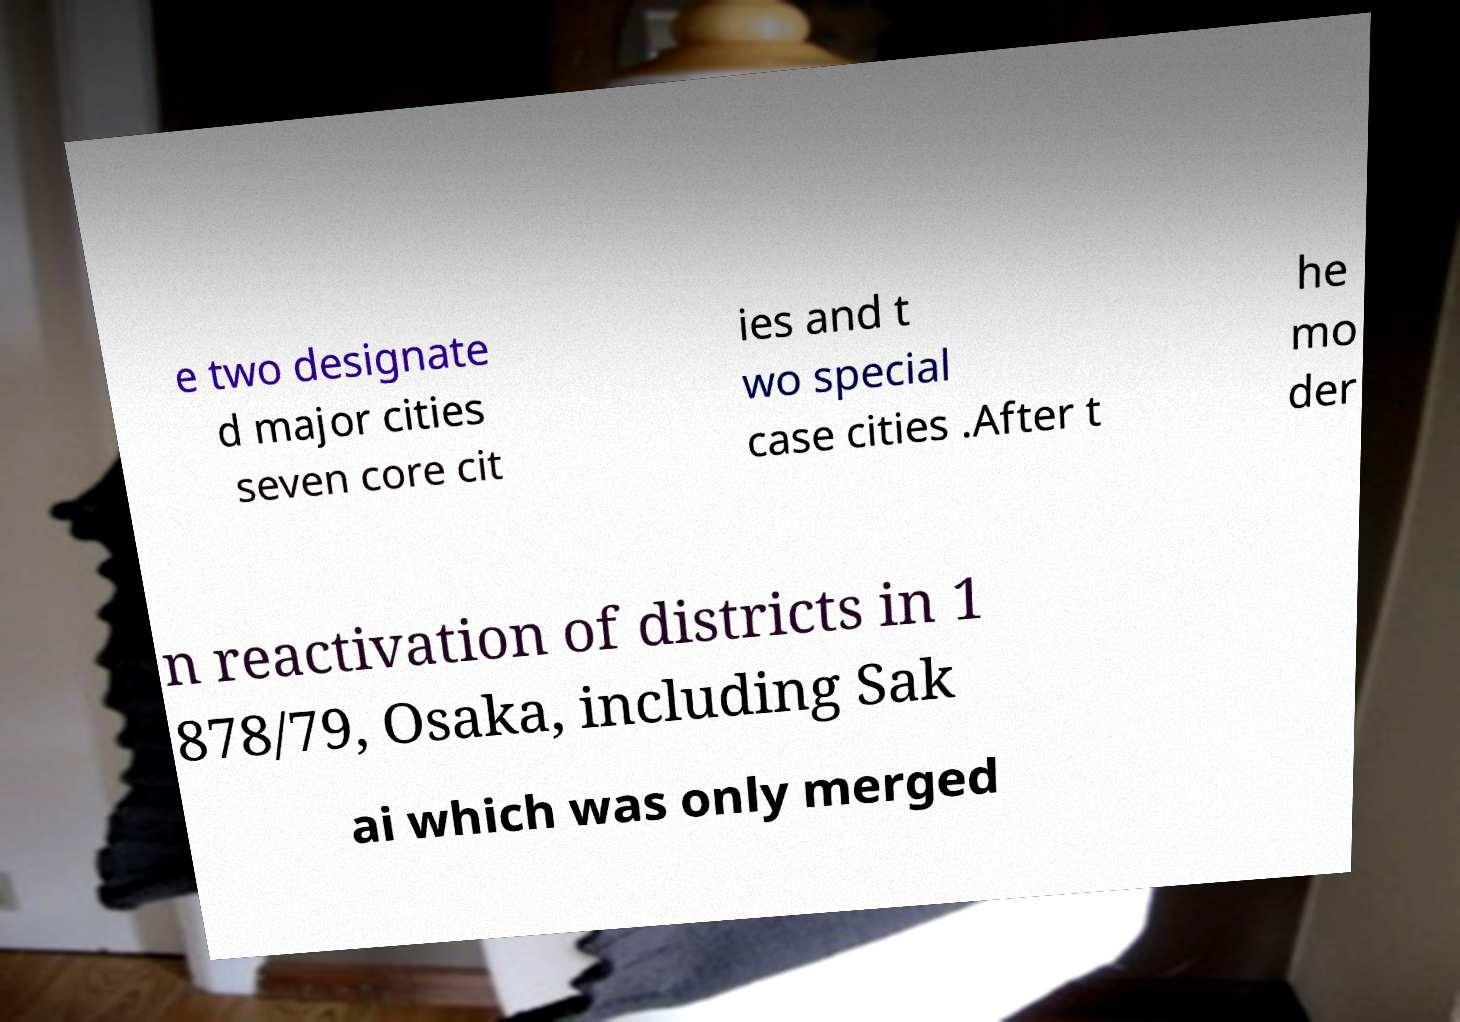Could you assist in decoding the text presented in this image and type it out clearly? e two designate d major cities seven core cit ies and t wo special case cities .After t he mo der n reactivation of districts in 1 878/79, Osaka, including Sak ai which was only merged 